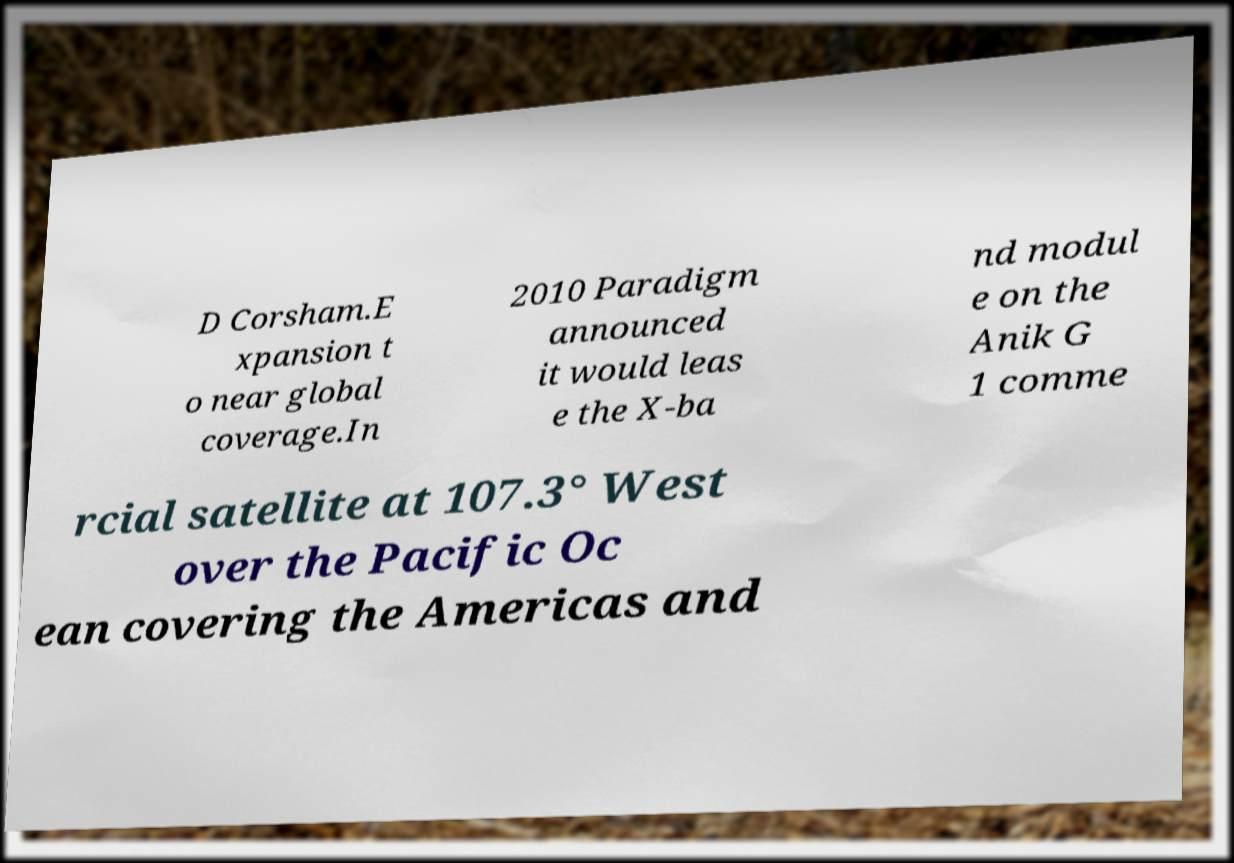Could you assist in decoding the text presented in this image and type it out clearly? D Corsham.E xpansion t o near global coverage.In 2010 Paradigm announced it would leas e the X-ba nd modul e on the Anik G 1 comme rcial satellite at 107.3° West over the Pacific Oc ean covering the Americas and 